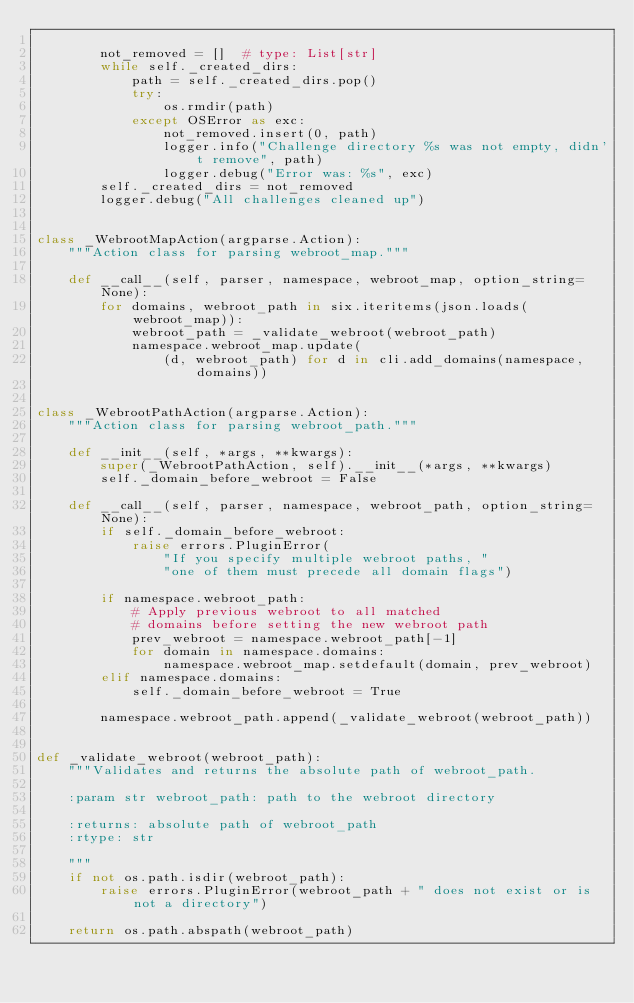<code> <loc_0><loc_0><loc_500><loc_500><_Python_>
        not_removed = []  # type: List[str]
        while self._created_dirs:
            path = self._created_dirs.pop()
            try:
                os.rmdir(path)
            except OSError as exc:
                not_removed.insert(0, path)
                logger.info("Challenge directory %s was not empty, didn't remove", path)
                logger.debug("Error was: %s", exc)
        self._created_dirs = not_removed
        logger.debug("All challenges cleaned up")


class _WebrootMapAction(argparse.Action):
    """Action class for parsing webroot_map."""

    def __call__(self, parser, namespace, webroot_map, option_string=None):
        for domains, webroot_path in six.iteritems(json.loads(webroot_map)):
            webroot_path = _validate_webroot(webroot_path)
            namespace.webroot_map.update(
                (d, webroot_path) for d in cli.add_domains(namespace, domains))


class _WebrootPathAction(argparse.Action):
    """Action class for parsing webroot_path."""

    def __init__(self, *args, **kwargs):
        super(_WebrootPathAction, self).__init__(*args, **kwargs)
        self._domain_before_webroot = False

    def __call__(self, parser, namespace, webroot_path, option_string=None):
        if self._domain_before_webroot:
            raise errors.PluginError(
                "If you specify multiple webroot paths, "
                "one of them must precede all domain flags")

        if namespace.webroot_path:
            # Apply previous webroot to all matched
            # domains before setting the new webroot path
            prev_webroot = namespace.webroot_path[-1]
            for domain in namespace.domains:
                namespace.webroot_map.setdefault(domain, prev_webroot)
        elif namespace.domains:
            self._domain_before_webroot = True

        namespace.webroot_path.append(_validate_webroot(webroot_path))


def _validate_webroot(webroot_path):
    """Validates and returns the absolute path of webroot_path.

    :param str webroot_path: path to the webroot directory

    :returns: absolute path of webroot_path
    :rtype: str

    """
    if not os.path.isdir(webroot_path):
        raise errors.PluginError(webroot_path + " does not exist or is not a directory")

    return os.path.abspath(webroot_path)
</code> 